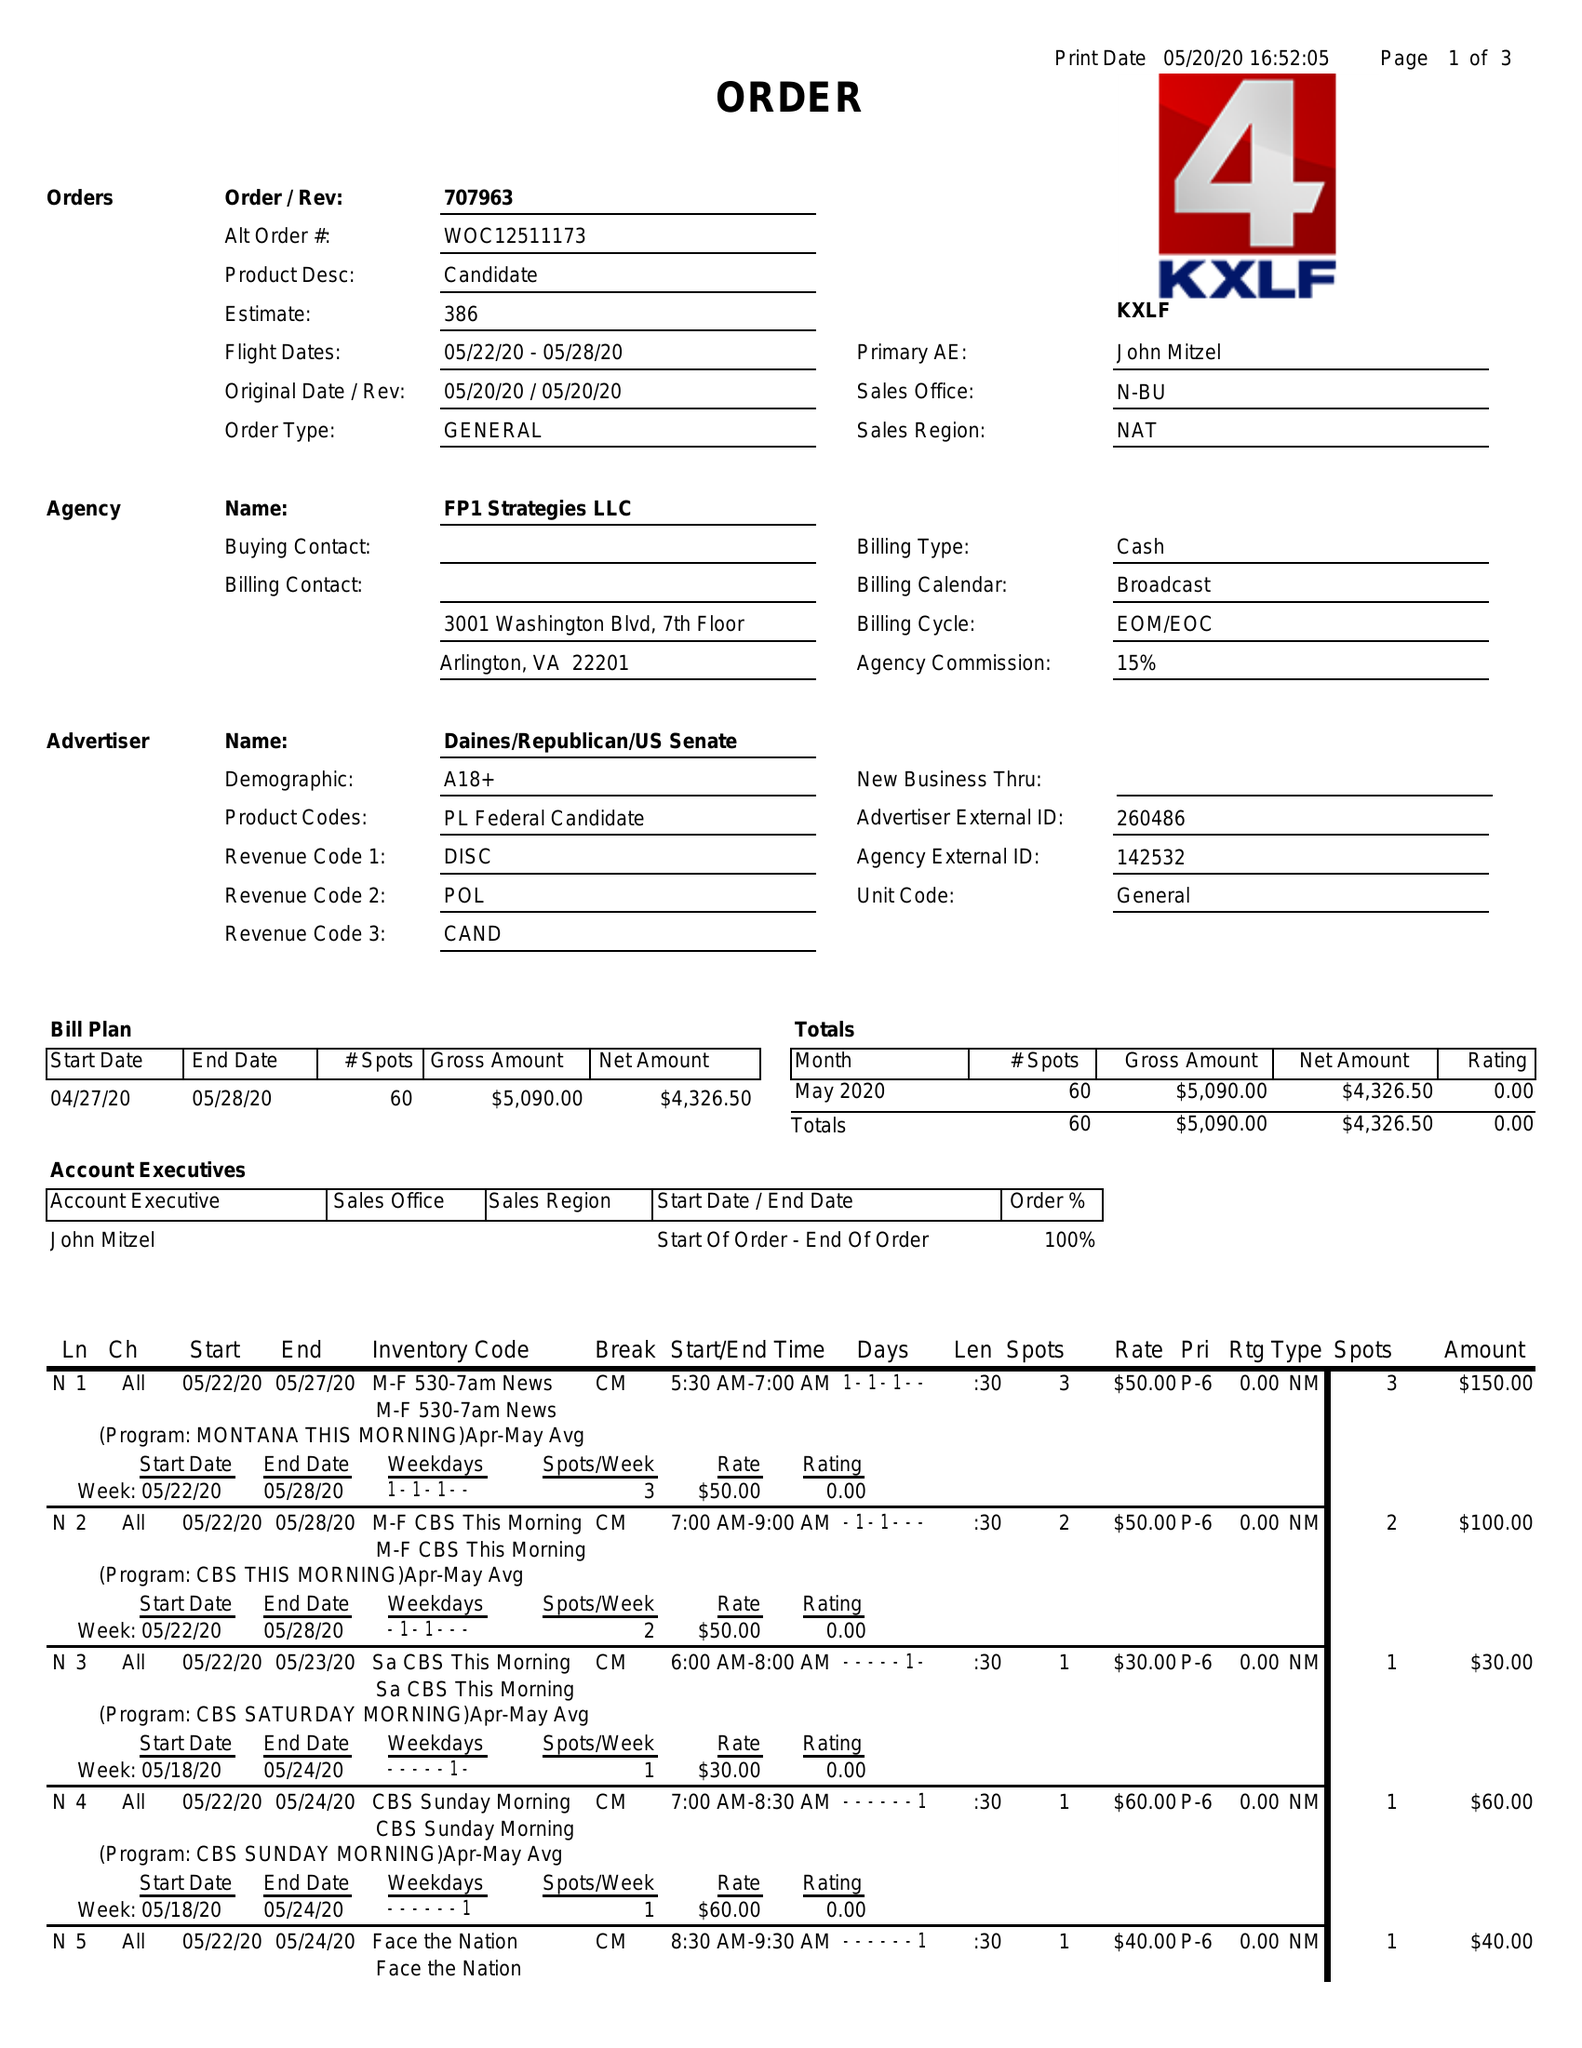What is the value for the gross_amount?
Answer the question using a single word or phrase. 5090.00 